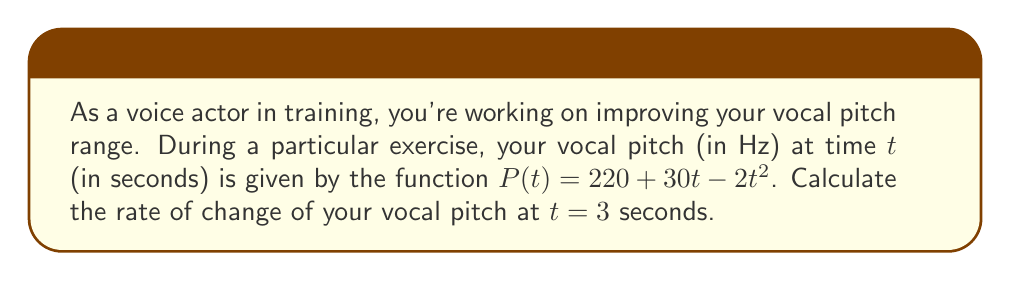Can you answer this question? To solve this problem, we need to follow these steps:

1) The rate of change of vocal pitch is represented by the derivative of the pitch function P(t) with respect to time t.

2) Given pitch function: $P(t) = 220 + 30t - 2t^2$

3) To find the derivative, we apply the power rule:
   $$\frac{dP}{dt} = 30 - 4t$$

4) This derivative function gives us the instantaneous rate of change of pitch at any time t.

5) We're asked to find the rate of change at t = 3 seconds, so we substitute t = 3 into our derivative function:

   $$\frac{dP}{dt}\bigg|_{t=3} = 30 - 4(3) = 30 - 12 = 18$$

6) The unit for the rate of change of pitch is Hz/s (Hertz per second).
Answer: The rate of change of vocal pitch at t = 3 seconds is 18 Hz/s. 